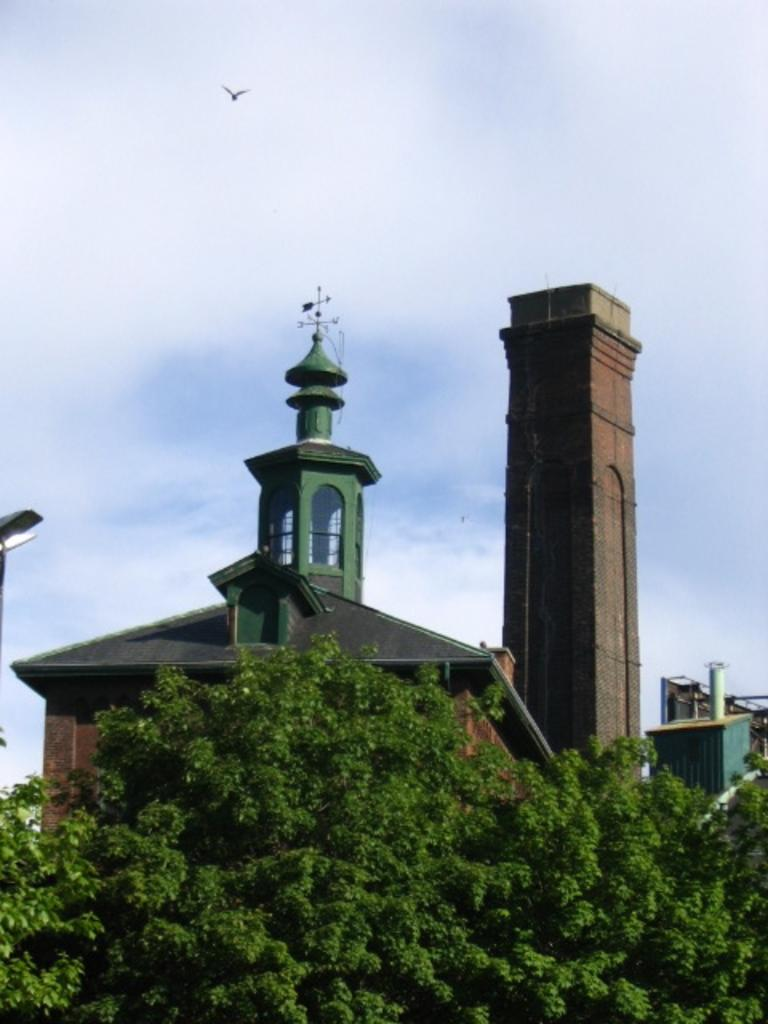What type of natural elements can be seen in the image? There are trees in the image. What type of man-made structures are visible in the image? There are buildings in the image. What other objects can be seen in the image besides trees and buildings? There are some objects in the image. What is happening in the sky in the background of the image? There is a bird flying in the sky in the background of the image. What type of tin can be seen being used in a volleyball game in the image? There is no tin or volleyball game present in the image. What is the cause of the argument between the two people in the image? There are no people or arguments present in the image. 